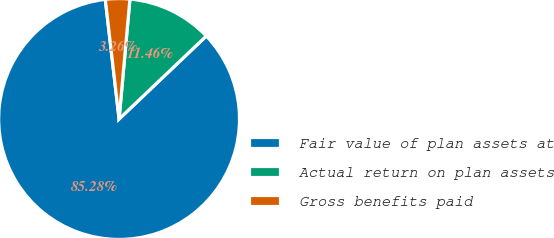Convert chart. <chart><loc_0><loc_0><loc_500><loc_500><pie_chart><fcel>Fair value of plan assets at<fcel>Actual return on plan assets<fcel>Gross benefits paid<nl><fcel>85.28%<fcel>11.46%<fcel>3.26%<nl></chart> 